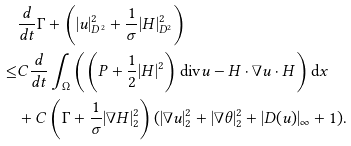Convert formula to latex. <formula><loc_0><loc_0><loc_500><loc_500>& \frac { d } { d t } \Gamma + \left ( | u | ^ { 2 } _ { D ^ { 2 } } + \frac { 1 } { \sigma } | H | ^ { 2 } _ { D ^ { 2 } } \right ) \\ \leq & C \frac { d } { d t } \int _ { \Omega } \left ( \left ( P + \frac { 1 } { 2 } | H | ^ { 2 } \right ) \text {div} u - H \cdot \nabla u \cdot H \right ) \text {d} x \\ & + C \left ( \Gamma + \frac { 1 } { \sigma } | \nabla H | ^ { 2 } _ { 2 } \right ) ( | \nabla u | ^ { 2 } _ { 2 } + | \nabla \theta | ^ { 2 } _ { 2 } + | D ( u ) | _ { \infty } + 1 ) .</formula> 